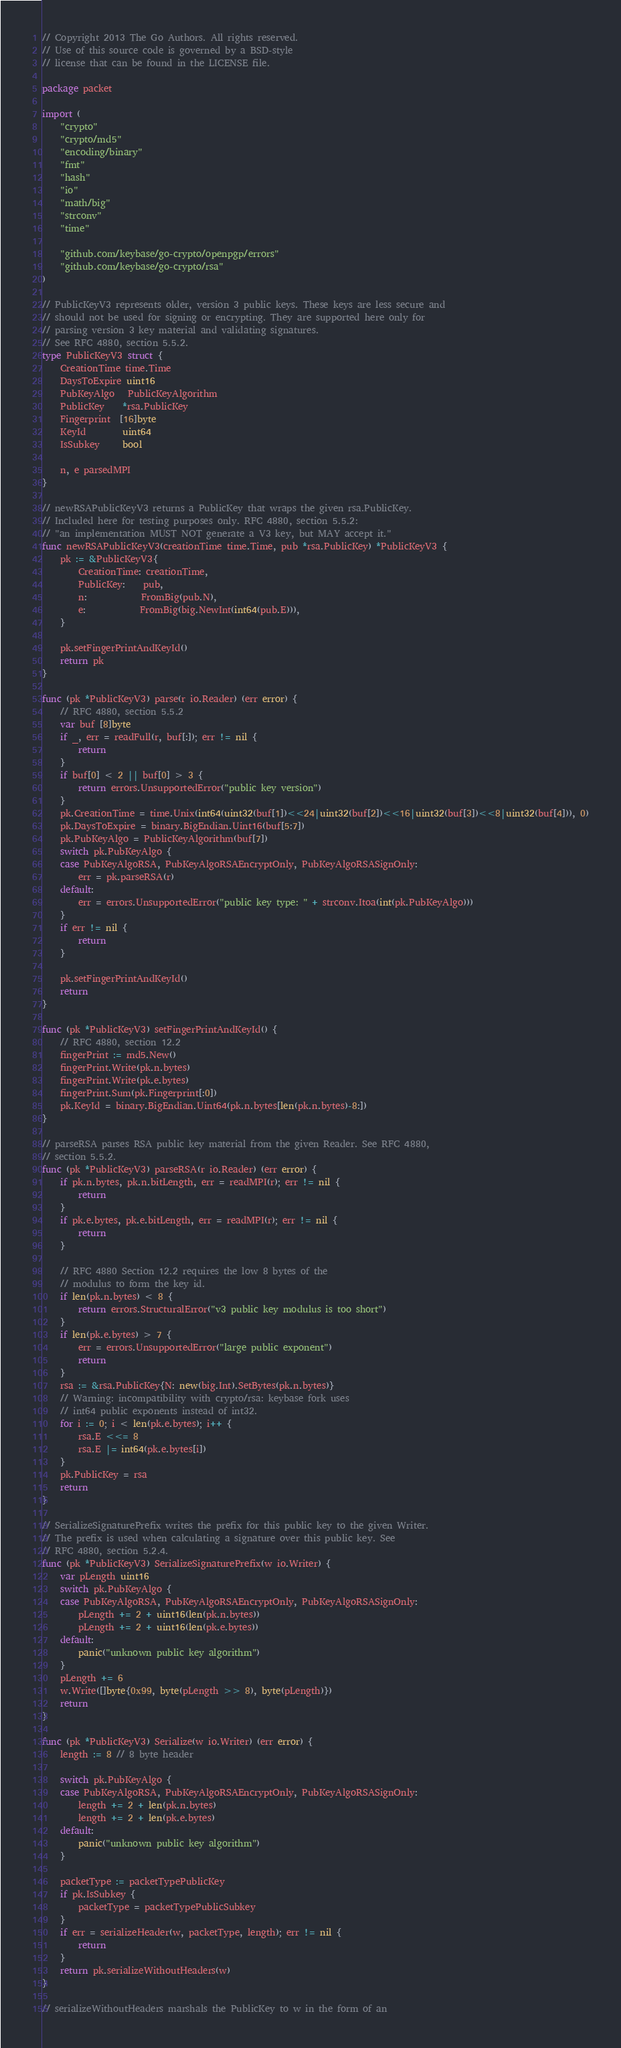<code> <loc_0><loc_0><loc_500><loc_500><_Go_>// Copyright 2013 The Go Authors. All rights reserved.
// Use of this source code is governed by a BSD-style
// license that can be found in the LICENSE file.

package packet

import (
	"crypto"
	"crypto/md5"
	"encoding/binary"
	"fmt"
	"hash"
	"io"
	"math/big"
	"strconv"
	"time"

	"github.com/keybase/go-crypto/openpgp/errors"
	"github.com/keybase/go-crypto/rsa"
)

// PublicKeyV3 represents older, version 3 public keys. These keys are less secure and
// should not be used for signing or encrypting. They are supported here only for
// parsing version 3 key material and validating signatures.
// See RFC 4880, section 5.5.2.
type PublicKeyV3 struct {
	CreationTime time.Time
	DaysToExpire uint16
	PubKeyAlgo   PublicKeyAlgorithm
	PublicKey    *rsa.PublicKey
	Fingerprint  [16]byte
	KeyId        uint64
	IsSubkey     bool

	n, e parsedMPI
}

// newRSAPublicKeyV3 returns a PublicKey that wraps the given rsa.PublicKey.
// Included here for testing purposes only. RFC 4880, section 5.5.2:
// "an implementation MUST NOT generate a V3 key, but MAY accept it."
func newRSAPublicKeyV3(creationTime time.Time, pub *rsa.PublicKey) *PublicKeyV3 {
	pk := &PublicKeyV3{
		CreationTime: creationTime,
		PublicKey:    pub,
		n:            FromBig(pub.N),
		e:            FromBig(big.NewInt(int64(pub.E))),
	}

	pk.setFingerPrintAndKeyId()
	return pk
}

func (pk *PublicKeyV3) parse(r io.Reader) (err error) {
	// RFC 4880, section 5.5.2
	var buf [8]byte
	if _, err = readFull(r, buf[:]); err != nil {
		return
	}
	if buf[0] < 2 || buf[0] > 3 {
		return errors.UnsupportedError("public key version")
	}
	pk.CreationTime = time.Unix(int64(uint32(buf[1])<<24|uint32(buf[2])<<16|uint32(buf[3])<<8|uint32(buf[4])), 0)
	pk.DaysToExpire = binary.BigEndian.Uint16(buf[5:7])
	pk.PubKeyAlgo = PublicKeyAlgorithm(buf[7])
	switch pk.PubKeyAlgo {
	case PubKeyAlgoRSA, PubKeyAlgoRSAEncryptOnly, PubKeyAlgoRSASignOnly:
		err = pk.parseRSA(r)
	default:
		err = errors.UnsupportedError("public key type: " + strconv.Itoa(int(pk.PubKeyAlgo)))
	}
	if err != nil {
		return
	}

	pk.setFingerPrintAndKeyId()
	return
}

func (pk *PublicKeyV3) setFingerPrintAndKeyId() {
	// RFC 4880, section 12.2
	fingerPrint := md5.New()
	fingerPrint.Write(pk.n.bytes)
	fingerPrint.Write(pk.e.bytes)
	fingerPrint.Sum(pk.Fingerprint[:0])
	pk.KeyId = binary.BigEndian.Uint64(pk.n.bytes[len(pk.n.bytes)-8:])
}

// parseRSA parses RSA public key material from the given Reader. See RFC 4880,
// section 5.5.2.
func (pk *PublicKeyV3) parseRSA(r io.Reader) (err error) {
	if pk.n.bytes, pk.n.bitLength, err = readMPI(r); err != nil {
		return
	}
	if pk.e.bytes, pk.e.bitLength, err = readMPI(r); err != nil {
		return
	}

	// RFC 4880 Section 12.2 requires the low 8 bytes of the
	// modulus to form the key id.
	if len(pk.n.bytes) < 8 {
		return errors.StructuralError("v3 public key modulus is too short")
	}
	if len(pk.e.bytes) > 7 {
		err = errors.UnsupportedError("large public exponent")
		return
	}
	rsa := &rsa.PublicKey{N: new(big.Int).SetBytes(pk.n.bytes)}
	// Warning: incompatibility with crypto/rsa: keybase fork uses
	// int64 public exponents instead of int32.
	for i := 0; i < len(pk.e.bytes); i++ {
		rsa.E <<= 8
		rsa.E |= int64(pk.e.bytes[i])
	}
	pk.PublicKey = rsa
	return
}

// SerializeSignaturePrefix writes the prefix for this public key to the given Writer.
// The prefix is used when calculating a signature over this public key. See
// RFC 4880, section 5.2.4.
func (pk *PublicKeyV3) SerializeSignaturePrefix(w io.Writer) {
	var pLength uint16
	switch pk.PubKeyAlgo {
	case PubKeyAlgoRSA, PubKeyAlgoRSAEncryptOnly, PubKeyAlgoRSASignOnly:
		pLength += 2 + uint16(len(pk.n.bytes))
		pLength += 2 + uint16(len(pk.e.bytes))
	default:
		panic("unknown public key algorithm")
	}
	pLength += 6
	w.Write([]byte{0x99, byte(pLength >> 8), byte(pLength)})
	return
}

func (pk *PublicKeyV3) Serialize(w io.Writer) (err error) {
	length := 8 // 8 byte header

	switch pk.PubKeyAlgo {
	case PubKeyAlgoRSA, PubKeyAlgoRSAEncryptOnly, PubKeyAlgoRSASignOnly:
		length += 2 + len(pk.n.bytes)
		length += 2 + len(pk.e.bytes)
	default:
		panic("unknown public key algorithm")
	}

	packetType := packetTypePublicKey
	if pk.IsSubkey {
		packetType = packetTypePublicSubkey
	}
	if err = serializeHeader(w, packetType, length); err != nil {
		return
	}
	return pk.serializeWithoutHeaders(w)
}

// serializeWithoutHeaders marshals the PublicKey to w in the form of an</code> 